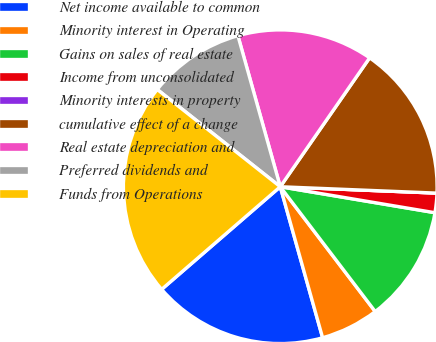Convert chart to OTSL. <chart><loc_0><loc_0><loc_500><loc_500><pie_chart><fcel>Net income available to common<fcel>Minority interest in Operating<fcel>Gains on sales of real estate<fcel>Income from unconsolidated<fcel>Minority interests in property<fcel>cumulative effect of a change<fcel>Real estate depreciation and<fcel>Preferred dividends and<fcel>Funds from Operations<nl><fcel>18.0%<fcel>6.0%<fcel>12.0%<fcel>2.0%<fcel>0.0%<fcel>16.0%<fcel>14.0%<fcel>10.0%<fcel>22.0%<nl></chart> 